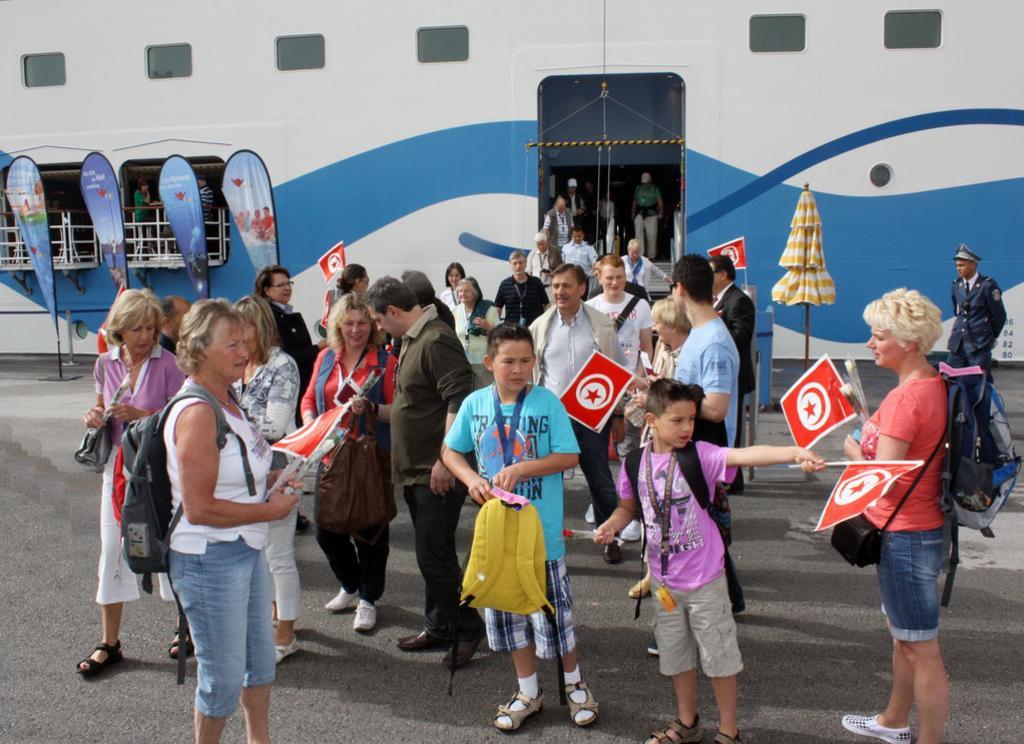Please provide a concise description of this image. In this image there are persons standing and walking and there are persons holding flags in their hands. In the background there is a tent which is yellow in colour and there is a building and there are persons standing inside the building and there is a railing and there are objects in front of the railing. 